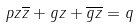Convert formula to latex. <formula><loc_0><loc_0><loc_500><loc_500>p z \overline { z } + g z + \overline { g z } = q</formula> 